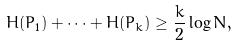<formula> <loc_0><loc_0><loc_500><loc_500>H ( P _ { 1 } ) + \dots + H ( P _ { k } ) \geq \frac { k } { 2 } \log N ,</formula> 